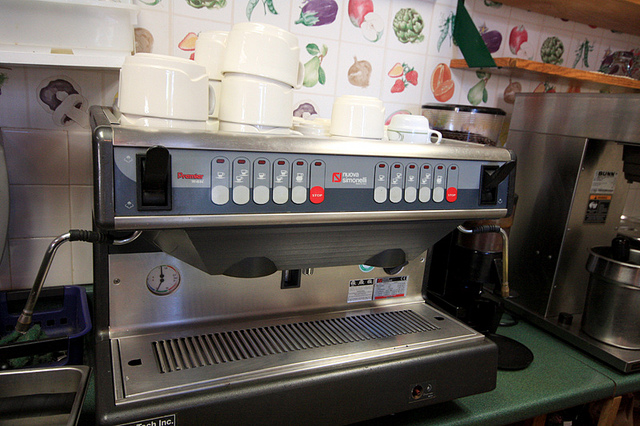What type of machine is this? This is a professional espresso machine, often used in coffee shops to make various espresso-based drinks. 